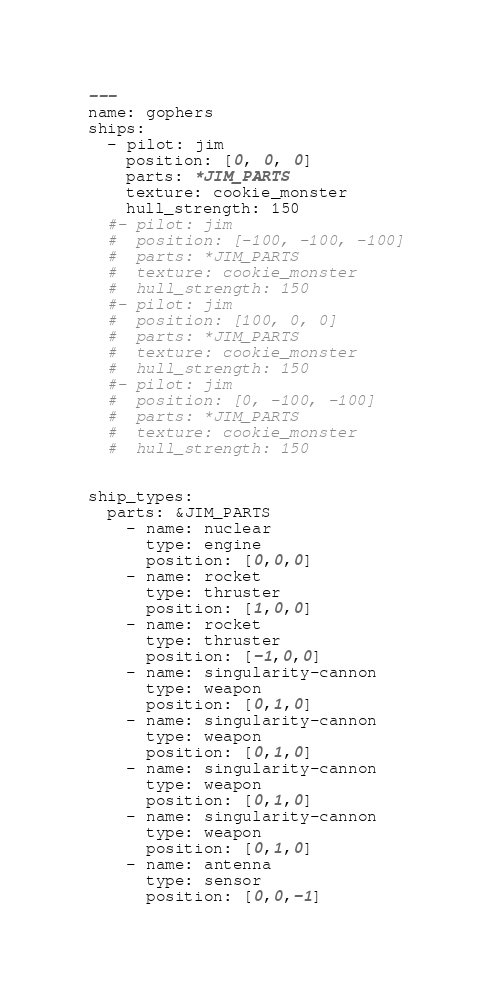Convert code to text. <code><loc_0><loc_0><loc_500><loc_500><_YAML_>---
name: gophers
ships:
  - pilot: jim
    position: [0, 0, 0]
    parts: *JIM_PARTS
    texture: cookie_monster
    hull_strength: 150
  #- pilot: jim
  #  position: [-100, -100, -100]
  #  parts: *JIM_PARTS
  #  texture: cookie_monster
  #  hull_strength: 150
  #- pilot: jim
  #  position: [100, 0, 0]
  #  parts: *JIM_PARTS
  #  texture: cookie_monster
  #  hull_strength: 150
  #- pilot: jim
  #  position: [0, -100, -100]
  #  parts: *JIM_PARTS
  #  texture: cookie_monster
  #  hull_strength: 150


ship_types:
  parts: &JIM_PARTS
    - name: nuclear
      type: engine
      position: [0,0,0]
    - name: rocket
      type: thruster
      position: [1,0,0]
    - name: rocket
      type: thruster
      position: [-1,0,0]
    - name: singularity-cannon
      type: weapon
      position: [0,1,0]
    - name: singularity-cannon
      type: weapon
      position: [0,1,0]
    - name: singularity-cannon
      type: weapon
      position: [0,1,0]
    - name: singularity-cannon
      type: weapon
      position: [0,1,0]
    - name: antenna
      type: sensor
      position: [0,0,-1]
</code> 